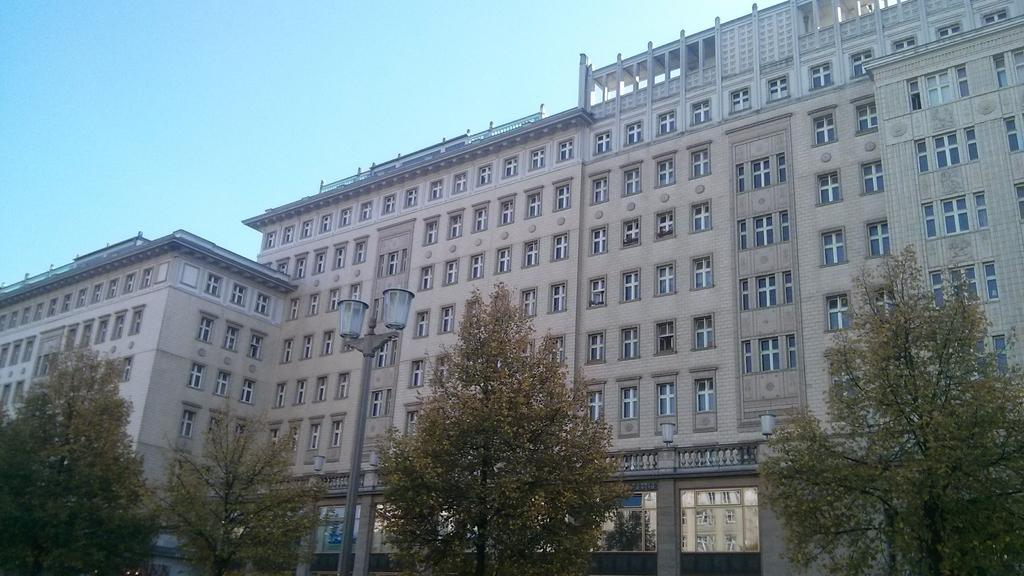Please provide a concise description of this image. In this picture I can see the buildings. At the bottom I can see many trees and street lights. On the building I can see many windows and doors. At the top I can see the sky. 